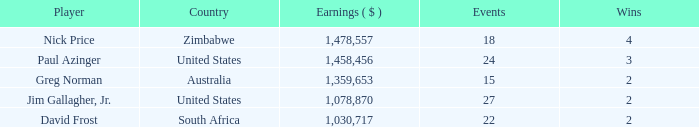Can you give me this table as a dict? {'header': ['Player', 'Country', 'Earnings ( $ )', 'Events', 'Wins'], 'rows': [['Nick Price', 'Zimbabwe', '1,478,557', '18', '4'], ['Paul Azinger', 'United States', '1,458,456', '24', '3'], ['Greg Norman', 'Australia', '1,359,653', '15', '2'], ['Jim Gallagher, Jr.', 'United States', '1,078,870', '27', '2'], ['David Frost', 'South Africa', '1,030,717', '22', '2']]} How many events have earnings less than 1,030,717? 0.0. 